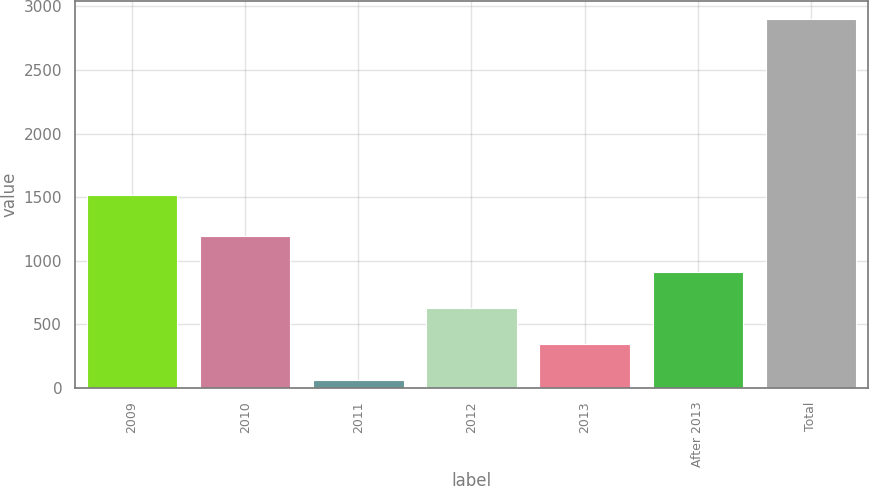<chart> <loc_0><loc_0><loc_500><loc_500><bar_chart><fcel>2009<fcel>2010<fcel>2011<fcel>2012<fcel>2013<fcel>After 2013<fcel>Total<nl><fcel>1520<fcel>1196<fcel>60<fcel>628<fcel>344<fcel>912<fcel>2900<nl></chart> 